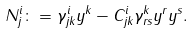<formula> <loc_0><loc_0><loc_500><loc_500>N ^ { i } _ { j } \colon = \gamma ^ { i } _ { j k } y ^ { k } - C ^ { i } _ { j k } \gamma ^ { k } _ { r s } y ^ { r } y ^ { s } .</formula> 